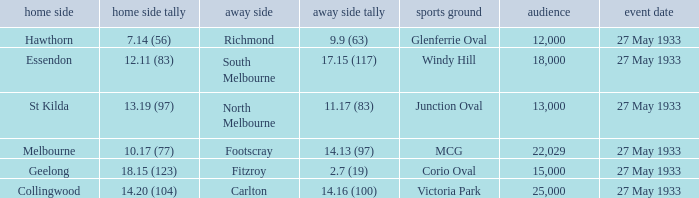During st kilda's home game, what was the number of people in the crowd? 13000.0. 